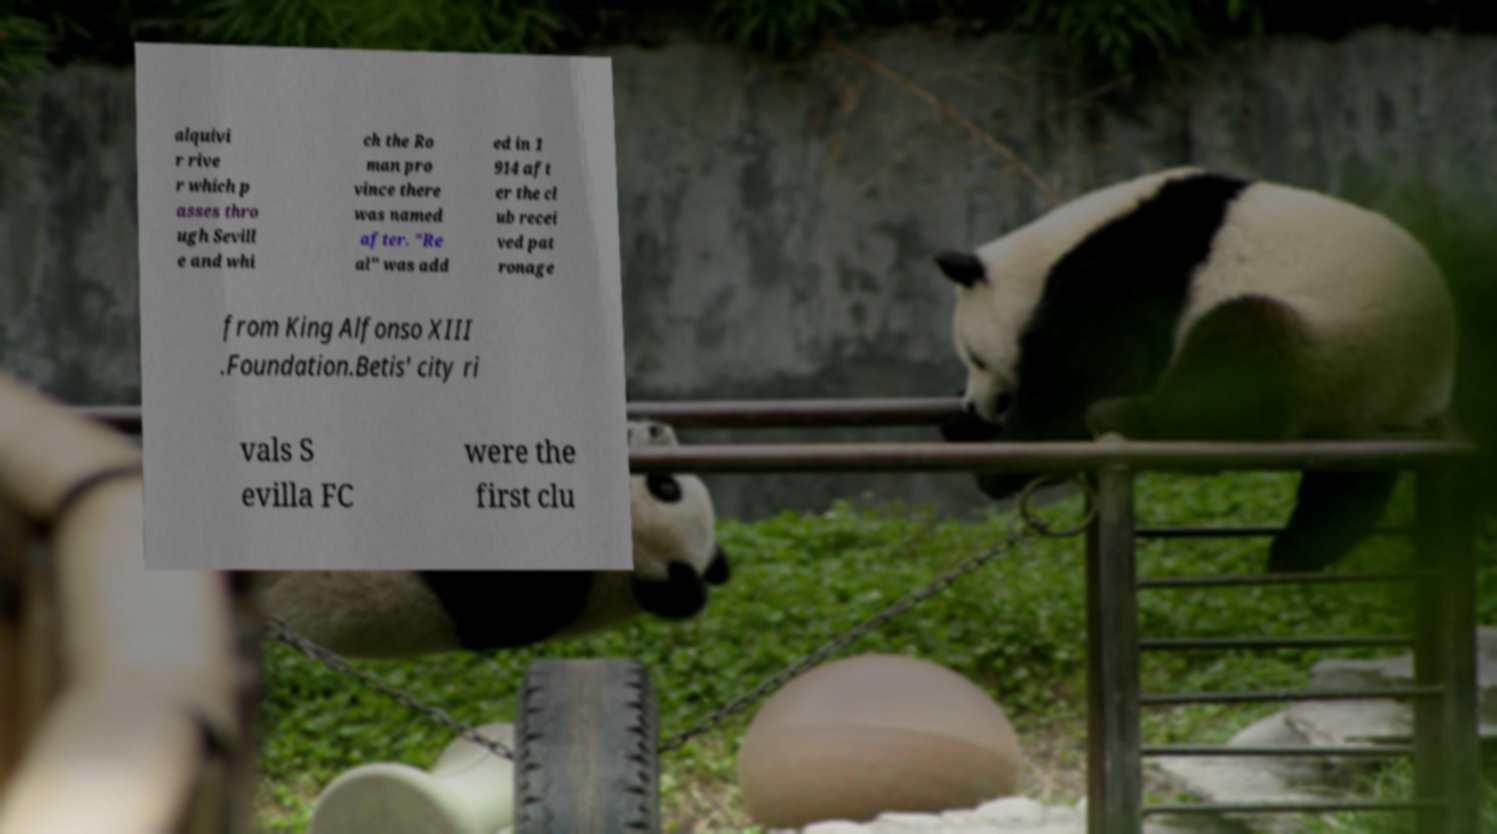Please read and relay the text visible in this image. What does it say? alquivi r rive r which p asses thro ugh Sevill e and whi ch the Ro man pro vince there was named after. "Re al" was add ed in 1 914 aft er the cl ub recei ved pat ronage from King Alfonso XIII .Foundation.Betis' city ri vals S evilla FC were the first clu 